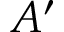<formula> <loc_0><loc_0><loc_500><loc_500>A ^ { \prime }</formula> 